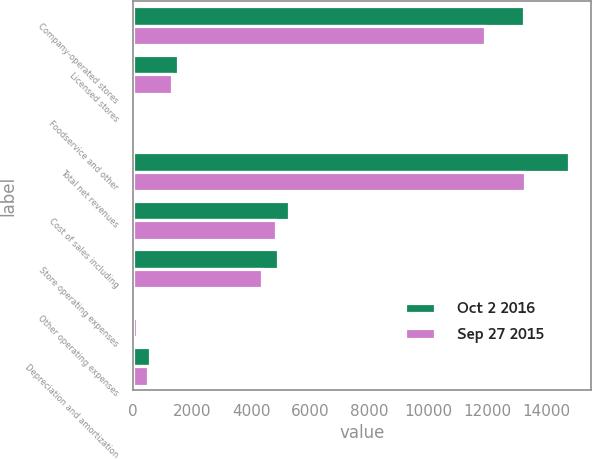Convert chart to OTSL. <chart><loc_0><loc_0><loc_500><loc_500><stacked_bar_chart><ecel><fcel>Company-operated stores<fcel>Licensed stores<fcel>Foodservice and other<fcel>Total net revenues<fcel>Cost of sales including<fcel>Store operating expenses<fcel>Other operating expenses<fcel>Depreciation and amortization<nl><fcel>Oct 2 2016<fcel>13247.4<fcel>1518.5<fcel>29.5<fcel>14795.4<fcel>5271.9<fcel>4909.3<fcel>96<fcel>590.1<nl><fcel>Sep 27 2015<fcel>11925.6<fcel>1334.4<fcel>33.4<fcel>13293.4<fcel>4845<fcel>4387.9<fcel>122.8<fcel>522.3<nl></chart> 